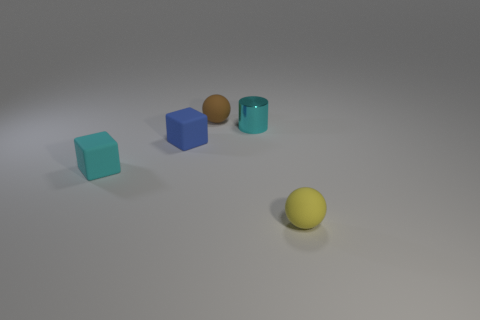There is a small yellow object that is made of the same material as the small brown thing; what is its shape?
Give a very brief answer. Sphere. Is the tiny yellow ball made of the same material as the small ball that is to the left of the yellow thing?
Ensure brevity in your answer.  Yes. Is there a tiny blue matte object that is to the right of the small matte sphere that is behind the tiny cyan metal cylinder?
Provide a short and direct response. No. There is a tiny yellow object that is the same shape as the tiny brown rubber thing; what is it made of?
Your response must be concise. Rubber. There is a small yellow thing that is on the right side of the small brown rubber object; how many small yellow balls are to the left of it?
Provide a short and direct response. 0. Is there anything else that is the same color as the tiny cylinder?
Make the answer very short. Yes. What number of things are either tiny purple cylinders or matte objects that are in front of the cyan cube?
Your response must be concise. 1. What material is the sphere behind the sphere in front of the small ball behind the cyan metallic cylinder?
Your answer should be very brief. Rubber. What size is the cyan cube that is made of the same material as the small brown thing?
Offer a terse response. Small. The rubber object in front of the small cyan rubber block in front of the brown ball is what color?
Offer a very short reply. Yellow. 